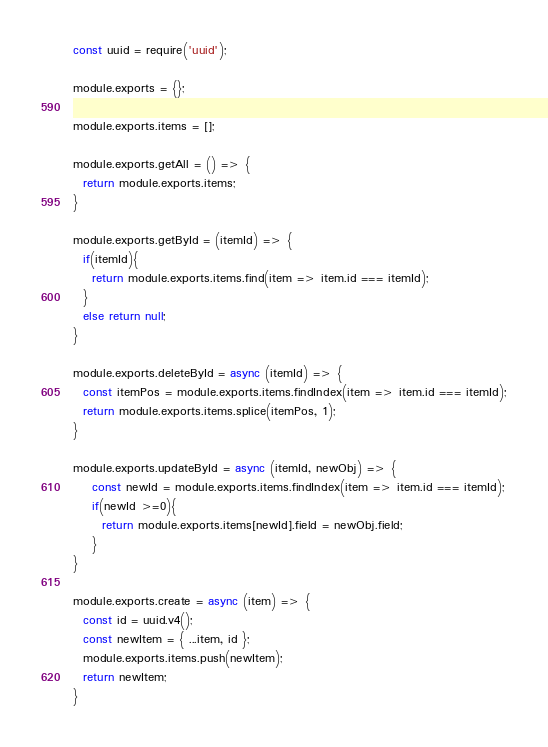<code> <loc_0><loc_0><loc_500><loc_500><_JavaScript_>const uuid = require('uuid');

module.exports = {};

module.exports.items = [];

module.exports.getAll = () => {
  return module.exports.items;
}

module.exports.getById = (itemId) => {
  if(itemId){
    return module.exports.items.find(item => item.id === itemId);
  }
  else return null;
}

module.exports.deleteById = async (itemId) => {
  const itemPos = module.exports.items.findIndex(item => item.id === itemId);
  return module.exports.items.splice(itemPos, 1);
}

module.exports.updateById = async (itemId, newObj) => {
    const newId = module.exports.items.findIndex(item => item.id === itemId);
    if(newId >=0){
      return module.exports.items[newId].field = newObj.field;
    }
}

module.exports.create = async (item) => {
  const id = uuid.v4();
  const newItem = { ...item, id };
  module.exports.items.push(newItem);
  return newItem;
}
</code> 